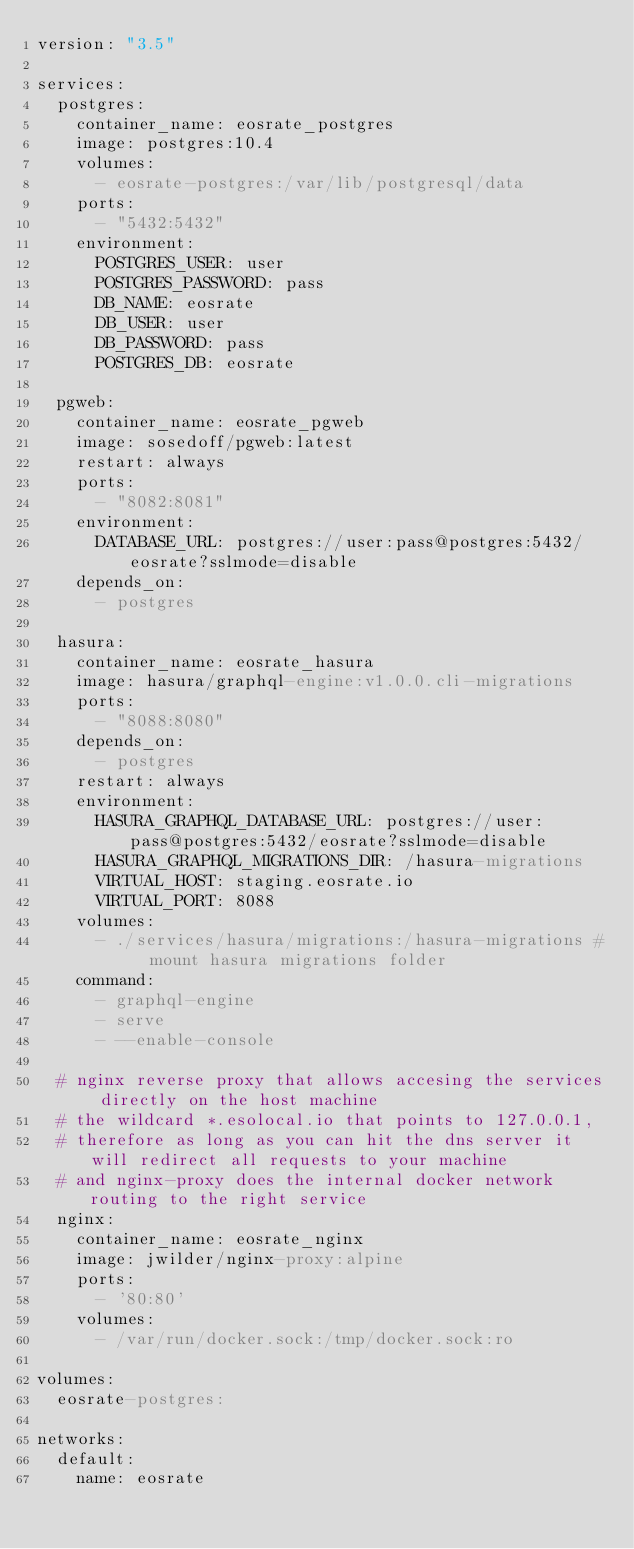<code> <loc_0><loc_0><loc_500><loc_500><_YAML_>version: "3.5"

services:
  postgres:
    container_name: eosrate_postgres
    image: postgres:10.4
    volumes:
      - eosrate-postgres:/var/lib/postgresql/data
    ports:
      - "5432:5432"
    environment:
      POSTGRES_USER: user
      POSTGRES_PASSWORD: pass
      DB_NAME: eosrate
      DB_USER: user
      DB_PASSWORD: pass
      POSTGRES_DB: eosrate

  pgweb:
    container_name: eosrate_pgweb
    image: sosedoff/pgweb:latest
    restart: always
    ports:
      - "8082:8081"
    environment:
      DATABASE_URL: postgres://user:pass@postgres:5432/eosrate?sslmode=disable
    depends_on:
      - postgres

  hasura:
    container_name: eosrate_hasura
    image: hasura/graphql-engine:v1.0.0.cli-migrations
    ports:
      - "8088:8080"
    depends_on:
      - postgres
    restart: always
    environment:
      HASURA_GRAPHQL_DATABASE_URL: postgres://user:pass@postgres:5432/eosrate?sslmode=disable
      HASURA_GRAPHQL_MIGRATIONS_DIR: /hasura-migrations
      VIRTUAL_HOST: staging.eosrate.io
      VIRTUAL_PORT: 8088
    volumes:
      - ./services/hasura/migrations:/hasura-migrations #  mount hasura migrations folder
    command:
      - graphql-engine
      - serve
      - --enable-console

  # nginx reverse proxy that allows accesing the services directly on the host machine
  # the wildcard *.esolocal.io that points to 127.0.0.1,
  # therefore as long as you can hit the dns server it will redirect all requests to your machine
  # and nginx-proxy does the internal docker network routing to the right service
  nginx:
    container_name: eosrate_nginx
    image: jwilder/nginx-proxy:alpine
    ports:
      - '80:80'
    volumes:
      - /var/run/docker.sock:/tmp/docker.sock:ro

volumes:
  eosrate-postgres:

networks:
  default:
    name: eosrate
</code> 